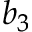<formula> <loc_0><loc_0><loc_500><loc_500>b _ { 3 }</formula> 